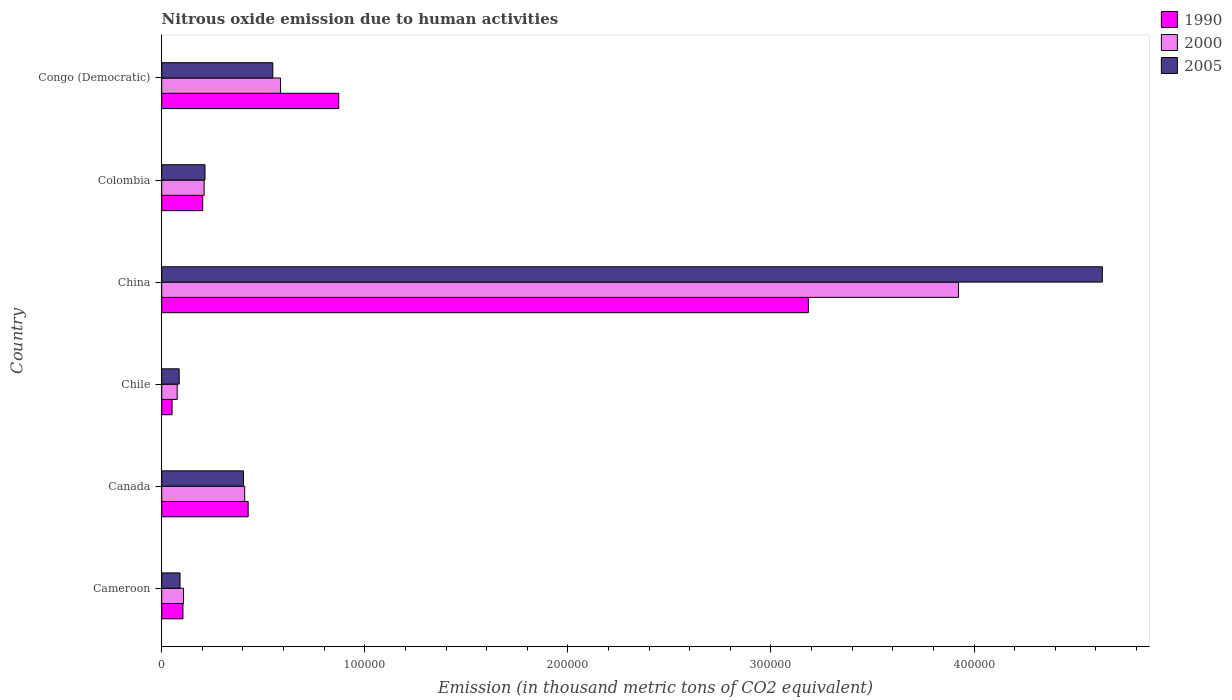How many different coloured bars are there?
Keep it short and to the point. 3. How many groups of bars are there?
Provide a short and direct response. 6. Are the number of bars per tick equal to the number of legend labels?
Offer a very short reply. Yes. Are the number of bars on each tick of the Y-axis equal?
Your answer should be very brief. Yes. What is the label of the 6th group of bars from the top?
Your answer should be very brief. Cameroon. In how many cases, is the number of bars for a given country not equal to the number of legend labels?
Provide a short and direct response. 0. What is the amount of nitrous oxide emitted in 1990 in Congo (Democratic)?
Your answer should be compact. 8.72e+04. Across all countries, what is the maximum amount of nitrous oxide emitted in 2005?
Provide a short and direct response. 4.63e+05. Across all countries, what is the minimum amount of nitrous oxide emitted in 2000?
Your answer should be very brief. 7617.9. In which country was the amount of nitrous oxide emitted in 2005 maximum?
Offer a very short reply. China. What is the total amount of nitrous oxide emitted in 1990 in the graph?
Provide a succinct answer. 4.84e+05. What is the difference between the amount of nitrous oxide emitted in 2005 in Chile and that in China?
Your answer should be very brief. -4.55e+05. What is the difference between the amount of nitrous oxide emitted in 2005 in Canada and the amount of nitrous oxide emitted in 2000 in Congo (Democratic)?
Make the answer very short. -1.83e+04. What is the average amount of nitrous oxide emitted in 2005 per country?
Your response must be concise. 9.95e+04. What is the difference between the amount of nitrous oxide emitted in 2005 and amount of nitrous oxide emitted in 2000 in Cameroon?
Offer a terse response. -1718.6. What is the ratio of the amount of nitrous oxide emitted in 2000 in Canada to that in Congo (Democratic)?
Ensure brevity in your answer.  0.7. Is the amount of nitrous oxide emitted in 1990 in Cameroon less than that in Congo (Democratic)?
Your response must be concise. Yes. Is the difference between the amount of nitrous oxide emitted in 2005 in Canada and Colombia greater than the difference between the amount of nitrous oxide emitted in 2000 in Canada and Colombia?
Your answer should be compact. No. What is the difference between the highest and the second highest amount of nitrous oxide emitted in 2000?
Offer a very short reply. 3.34e+05. What is the difference between the highest and the lowest amount of nitrous oxide emitted in 2005?
Give a very brief answer. 4.55e+05. In how many countries, is the amount of nitrous oxide emitted in 2000 greater than the average amount of nitrous oxide emitted in 2000 taken over all countries?
Ensure brevity in your answer.  1. What does the 1st bar from the top in Congo (Democratic) represents?
Provide a succinct answer. 2005. How many bars are there?
Provide a short and direct response. 18. Are all the bars in the graph horizontal?
Your answer should be compact. Yes. How many countries are there in the graph?
Your answer should be very brief. 6. What is the difference between two consecutive major ticks on the X-axis?
Offer a terse response. 1.00e+05. Are the values on the major ticks of X-axis written in scientific E-notation?
Offer a terse response. No. Does the graph contain grids?
Your answer should be very brief. No. Where does the legend appear in the graph?
Offer a very short reply. Top right. How many legend labels are there?
Offer a very short reply. 3. How are the legend labels stacked?
Keep it short and to the point. Vertical. What is the title of the graph?
Provide a short and direct response. Nitrous oxide emission due to human activities. Does "1974" appear as one of the legend labels in the graph?
Ensure brevity in your answer.  No. What is the label or title of the X-axis?
Ensure brevity in your answer.  Emission (in thousand metric tons of CO2 equivalent). What is the label or title of the Y-axis?
Your answer should be compact. Country. What is the Emission (in thousand metric tons of CO2 equivalent) of 1990 in Cameroon?
Your response must be concise. 1.05e+04. What is the Emission (in thousand metric tons of CO2 equivalent) of 2000 in Cameroon?
Provide a succinct answer. 1.07e+04. What is the Emission (in thousand metric tons of CO2 equivalent) in 2005 in Cameroon?
Make the answer very short. 9027.2. What is the Emission (in thousand metric tons of CO2 equivalent) of 1990 in Canada?
Your response must be concise. 4.26e+04. What is the Emission (in thousand metric tons of CO2 equivalent) in 2000 in Canada?
Ensure brevity in your answer.  4.09e+04. What is the Emission (in thousand metric tons of CO2 equivalent) of 2005 in Canada?
Ensure brevity in your answer.  4.02e+04. What is the Emission (in thousand metric tons of CO2 equivalent) of 1990 in Chile?
Provide a succinct answer. 5100.7. What is the Emission (in thousand metric tons of CO2 equivalent) of 2000 in Chile?
Offer a very short reply. 7617.9. What is the Emission (in thousand metric tons of CO2 equivalent) in 2005 in Chile?
Offer a very short reply. 8607.6. What is the Emission (in thousand metric tons of CO2 equivalent) of 1990 in China?
Give a very brief answer. 3.18e+05. What is the Emission (in thousand metric tons of CO2 equivalent) in 2000 in China?
Your answer should be very brief. 3.92e+05. What is the Emission (in thousand metric tons of CO2 equivalent) in 2005 in China?
Provide a succinct answer. 4.63e+05. What is the Emission (in thousand metric tons of CO2 equivalent) of 1990 in Colombia?
Give a very brief answer. 2.02e+04. What is the Emission (in thousand metric tons of CO2 equivalent) of 2000 in Colombia?
Your response must be concise. 2.09e+04. What is the Emission (in thousand metric tons of CO2 equivalent) of 2005 in Colombia?
Provide a succinct answer. 2.13e+04. What is the Emission (in thousand metric tons of CO2 equivalent) of 1990 in Congo (Democratic)?
Give a very brief answer. 8.72e+04. What is the Emission (in thousand metric tons of CO2 equivalent) in 2000 in Congo (Democratic)?
Provide a short and direct response. 5.85e+04. What is the Emission (in thousand metric tons of CO2 equivalent) of 2005 in Congo (Democratic)?
Provide a short and direct response. 5.47e+04. Across all countries, what is the maximum Emission (in thousand metric tons of CO2 equivalent) of 1990?
Offer a terse response. 3.18e+05. Across all countries, what is the maximum Emission (in thousand metric tons of CO2 equivalent) in 2000?
Keep it short and to the point. 3.92e+05. Across all countries, what is the maximum Emission (in thousand metric tons of CO2 equivalent) of 2005?
Offer a very short reply. 4.63e+05. Across all countries, what is the minimum Emission (in thousand metric tons of CO2 equivalent) of 1990?
Offer a terse response. 5100.7. Across all countries, what is the minimum Emission (in thousand metric tons of CO2 equivalent) in 2000?
Make the answer very short. 7617.9. Across all countries, what is the minimum Emission (in thousand metric tons of CO2 equivalent) of 2005?
Make the answer very short. 8607.6. What is the total Emission (in thousand metric tons of CO2 equivalent) of 1990 in the graph?
Provide a succinct answer. 4.84e+05. What is the total Emission (in thousand metric tons of CO2 equivalent) in 2000 in the graph?
Ensure brevity in your answer.  5.31e+05. What is the total Emission (in thousand metric tons of CO2 equivalent) in 2005 in the graph?
Offer a terse response. 5.97e+05. What is the difference between the Emission (in thousand metric tons of CO2 equivalent) of 1990 in Cameroon and that in Canada?
Offer a terse response. -3.21e+04. What is the difference between the Emission (in thousand metric tons of CO2 equivalent) in 2000 in Cameroon and that in Canada?
Your response must be concise. -3.01e+04. What is the difference between the Emission (in thousand metric tons of CO2 equivalent) in 2005 in Cameroon and that in Canada?
Provide a succinct answer. -3.12e+04. What is the difference between the Emission (in thousand metric tons of CO2 equivalent) of 1990 in Cameroon and that in Chile?
Offer a terse response. 5359.6. What is the difference between the Emission (in thousand metric tons of CO2 equivalent) of 2000 in Cameroon and that in Chile?
Make the answer very short. 3127.9. What is the difference between the Emission (in thousand metric tons of CO2 equivalent) of 2005 in Cameroon and that in Chile?
Your answer should be compact. 419.6. What is the difference between the Emission (in thousand metric tons of CO2 equivalent) in 1990 in Cameroon and that in China?
Give a very brief answer. -3.08e+05. What is the difference between the Emission (in thousand metric tons of CO2 equivalent) of 2000 in Cameroon and that in China?
Your response must be concise. -3.82e+05. What is the difference between the Emission (in thousand metric tons of CO2 equivalent) in 2005 in Cameroon and that in China?
Provide a succinct answer. -4.54e+05. What is the difference between the Emission (in thousand metric tons of CO2 equivalent) of 1990 in Cameroon and that in Colombia?
Your answer should be very brief. -9721.4. What is the difference between the Emission (in thousand metric tons of CO2 equivalent) in 2000 in Cameroon and that in Colombia?
Your answer should be compact. -1.01e+04. What is the difference between the Emission (in thousand metric tons of CO2 equivalent) in 2005 in Cameroon and that in Colombia?
Keep it short and to the point. -1.23e+04. What is the difference between the Emission (in thousand metric tons of CO2 equivalent) of 1990 in Cameroon and that in Congo (Democratic)?
Provide a succinct answer. -7.67e+04. What is the difference between the Emission (in thousand metric tons of CO2 equivalent) in 2000 in Cameroon and that in Congo (Democratic)?
Provide a short and direct response. -4.78e+04. What is the difference between the Emission (in thousand metric tons of CO2 equivalent) of 2005 in Cameroon and that in Congo (Democratic)?
Ensure brevity in your answer.  -4.57e+04. What is the difference between the Emission (in thousand metric tons of CO2 equivalent) in 1990 in Canada and that in Chile?
Keep it short and to the point. 3.75e+04. What is the difference between the Emission (in thousand metric tons of CO2 equivalent) of 2000 in Canada and that in Chile?
Offer a terse response. 3.32e+04. What is the difference between the Emission (in thousand metric tons of CO2 equivalent) of 2005 in Canada and that in Chile?
Give a very brief answer. 3.16e+04. What is the difference between the Emission (in thousand metric tons of CO2 equivalent) in 1990 in Canada and that in China?
Ensure brevity in your answer.  -2.76e+05. What is the difference between the Emission (in thousand metric tons of CO2 equivalent) of 2000 in Canada and that in China?
Offer a very short reply. -3.52e+05. What is the difference between the Emission (in thousand metric tons of CO2 equivalent) of 2005 in Canada and that in China?
Give a very brief answer. -4.23e+05. What is the difference between the Emission (in thousand metric tons of CO2 equivalent) in 1990 in Canada and that in Colombia?
Give a very brief answer. 2.24e+04. What is the difference between the Emission (in thousand metric tons of CO2 equivalent) in 2000 in Canada and that in Colombia?
Offer a very short reply. 2.00e+04. What is the difference between the Emission (in thousand metric tons of CO2 equivalent) in 2005 in Canada and that in Colombia?
Ensure brevity in your answer.  1.89e+04. What is the difference between the Emission (in thousand metric tons of CO2 equivalent) of 1990 in Canada and that in Congo (Democratic)?
Offer a terse response. -4.46e+04. What is the difference between the Emission (in thousand metric tons of CO2 equivalent) in 2000 in Canada and that in Congo (Democratic)?
Your answer should be very brief. -1.77e+04. What is the difference between the Emission (in thousand metric tons of CO2 equivalent) of 2005 in Canada and that in Congo (Democratic)?
Provide a succinct answer. -1.45e+04. What is the difference between the Emission (in thousand metric tons of CO2 equivalent) of 1990 in Chile and that in China?
Provide a short and direct response. -3.13e+05. What is the difference between the Emission (in thousand metric tons of CO2 equivalent) in 2000 in Chile and that in China?
Your answer should be very brief. -3.85e+05. What is the difference between the Emission (in thousand metric tons of CO2 equivalent) in 2005 in Chile and that in China?
Your answer should be compact. -4.55e+05. What is the difference between the Emission (in thousand metric tons of CO2 equivalent) in 1990 in Chile and that in Colombia?
Your answer should be very brief. -1.51e+04. What is the difference between the Emission (in thousand metric tons of CO2 equivalent) of 2000 in Chile and that in Colombia?
Keep it short and to the point. -1.33e+04. What is the difference between the Emission (in thousand metric tons of CO2 equivalent) of 2005 in Chile and that in Colombia?
Your response must be concise. -1.27e+04. What is the difference between the Emission (in thousand metric tons of CO2 equivalent) of 1990 in Chile and that in Congo (Democratic)?
Ensure brevity in your answer.  -8.21e+04. What is the difference between the Emission (in thousand metric tons of CO2 equivalent) of 2000 in Chile and that in Congo (Democratic)?
Your response must be concise. -5.09e+04. What is the difference between the Emission (in thousand metric tons of CO2 equivalent) of 2005 in Chile and that in Congo (Democratic)?
Make the answer very short. -4.61e+04. What is the difference between the Emission (in thousand metric tons of CO2 equivalent) of 1990 in China and that in Colombia?
Your answer should be compact. 2.98e+05. What is the difference between the Emission (in thousand metric tons of CO2 equivalent) in 2000 in China and that in Colombia?
Offer a terse response. 3.71e+05. What is the difference between the Emission (in thousand metric tons of CO2 equivalent) of 2005 in China and that in Colombia?
Give a very brief answer. 4.42e+05. What is the difference between the Emission (in thousand metric tons of CO2 equivalent) of 1990 in China and that in Congo (Democratic)?
Your response must be concise. 2.31e+05. What is the difference between the Emission (in thousand metric tons of CO2 equivalent) of 2000 in China and that in Congo (Democratic)?
Your response must be concise. 3.34e+05. What is the difference between the Emission (in thousand metric tons of CO2 equivalent) in 2005 in China and that in Congo (Democratic)?
Give a very brief answer. 4.08e+05. What is the difference between the Emission (in thousand metric tons of CO2 equivalent) of 1990 in Colombia and that in Congo (Democratic)?
Make the answer very short. -6.70e+04. What is the difference between the Emission (in thousand metric tons of CO2 equivalent) of 2000 in Colombia and that in Congo (Democratic)?
Keep it short and to the point. -3.76e+04. What is the difference between the Emission (in thousand metric tons of CO2 equivalent) of 2005 in Colombia and that in Congo (Democratic)?
Ensure brevity in your answer.  -3.34e+04. What is the difference between the Emission (in thousand metric tons of CO2 equivalent) of 1990 in Cameroon and the Emission (in thousand metric tons of CO2 equivalent) of 2000 in Canada?
Your answer should be compact. -3.04e+04. What is the difference between the Emission (in thousand metric tons of CO2 equivalent) in 1990 in Cameroon and the Emission (in thousand metric tons of CO2 equivalent) in 2005 in Canada?
Your answer should be very brief. -2.98e+04. What is the difference between the Emission (in thousand metric tons of CO2 equivalent) of 2000 in Cameroon and the Emission (in thousand metric tons of CO2 equivalent) of 2005 in Canada?
Your response must be concise. -2.95e+04. What is the difference between the Emission (in thousand metric tons of CO2 equivalent) of 1990 in Cameroon and the Emission (in thousand metric tons of CO2 equivalent) of 2000 in Chile?
Provide a succinct answer. 2842.4. What is the difference between the Emission (in thousand metric tons of CO2 equivalent) in 1990 in Cameroon and the Emission (in thousand metric tons of CO2 equivalent) in 2005 in Chile?
Keep it short and to the point. 1852.7. What is the difference between the Emission (in thousand metric tons of CO2 equivalent) in 2000 in Cameroon and the Emission (in thousand metric tons of CO2 equivalent) in 2005 in Chile?
Your answer should be compact. 2138.2. What is the difference between the Emission (in thousand metric tons of CO2 equivalent) of 1990 in Cameroon and the Emission (in thousand metric tons of CO2 equivalent) of 2000 in China?
Your answer should be compact. -3.82e+05. What is the difference between the Emission (in thousand metric tons of CO2 equivalent) in 1990 in Cameroon and the Emission (in thousand metric tons of CO2 equivalent) in 2005 in China?
Make the answer very short. -4.53e+05. What is the difference between the Emission (in thousand metric tons of CO2 equivalent) of 2000 in Cameroon and the Emission (in thousand metric tons of CO2 equivalent) of 2005 in China?
Provide a succinct answer. -4.52e+05. What is the difference between the Emission (in thousand metric tons of CO2 equivalent) of 1990 in Cameroon and the Emission (in thousand metric tons of CO2 equivalent) of 2000 in Colombia?
Provide a short and direct response. -1.04e+04. What is the difference between the Emission (in thousand metric tons of CO2 equivalent) in 1990 in Cameroon and the Emission (in thousand metric tons of CO2 equivalent) in 2005 in Colombia?
Your answer should be very brief. -1.09e+04. What is the difference between the Emission (in thousand metric tons of CO2 equivalent) in 2000 in Cameroon and the Emission (in thousand metric tons of CO2 equivalent) in 2005 in Colombia?
Provide a short and direct response. -1.06e+04. What is the difference between the Emission (in thousand metric tons of CO2 equivalent) of 1990 in Cameroon and the Emission (in thousand metric tons of CO2 equivalent) of 2000 in Congo (Democratic)?
Offer a terse response. -4.81e+04. What is the difference between the Emission (in thousand metric tons of CO2 equivalent) in 1990 in Cameroon and the Emission (in thousand metric tons of CO2 equivalent) in 2005 in Congo (Democratic)?
Your response must be concise. -4.42e+04. What is the difference between the Emission (in thousand metric tons of CO2 equivalent) in 2000 in Cameroon and the Emission (in thousand metric tons of CO2 equivalent) in 2005 in Congo (Democratic)?
Keep it short and to the point. -4.40e+04. What is the difference between the Emission (in thousand metric tons of CO2 equivalent) in 1990 in Canada and the Emission (in thousand metric tons of CO2 equivalent) in 2000 in Chile?
Provide a short and direct response. 3.50e+04. What is the difference between the Emission (in thousand metric tons of CO2 equivalent) of 1990 in Canada and the Emission (in thousand metric tons of CO2 equivalent) of 2005 in Chile?
Provide a succinct answer. 3.40e+04. What is the difference between the Emission (in thousand metric tons of CO2 equivalent) in 2000 in Canada and the Emission (in thousand metric tons of CO2 equivalent) in 2005 in Chile?
Provide a succinct answer. 3.23e+04. What is the difference between the Emission (in thousand metric tons of CO2 equivalent) in 1990 in Canada and the Emission (in thousand metric tons of CO2 equivalent) in 2000 in China?
Provide a succinct answer. -3.50e+05. What is the difference between the Emission (in thousand metric tons of CO2 equivalent) of 1990 in Canada and the Emission (in thousand metric tons of CO2 equivalent) of 2005 in China?
Make the answer very short. -4.21e+05. What is the difference between the Emission (in thousand metric tons of CO2 equivalent) in 2000 in Canada and the Emission (in thousand metric tons of CO2 equivalent) in 2005 in China?
Provide a short and direct response. -4.22e+05. What is the difference between the Emission (in thousand metric tons of CO2 equivalent) of 1990 in Canada and the Emission (in thousand metric tons of CO2 equivalent) of 2000 in Colombia?
Provide a succinct answer. 2.17e+04. What is the difference between the Emission (in thousand metric tons of CO2 equivalent) of 1990 in Canada and the Emission (in thousand metric tons of CO2 equivalent) of 2005 in Colombia?
Keep it short and to the point. 2.13e+04. What is the difference between the Emission (in thousand metric tons of CO2 equivalent) in 2000 in Canada and the Emission (in thousand metric tons of CO2 equivalent) in 2005 in Colombia?
Ensure brevity in your answer.  1.95e+04. What is the difference between the Emission (in thousand metric tons of CO2 equivalent) of 1990 in Canada and the Emission (in thousand metric tons of CO2 equivalent) of 2000 in Congo (Democratic)?
Give a very brief answer. -1.60e+04. What is the difference between the Emission (in thousand metric tons of CO2 equivalent) of 1990 in Canada and the Emission (in thousand metric tons of CO2 equivalent) of 2005 in Congo (Democratic)?
Provide a succinct answer. -1.21e+04. What is the difference between the Emission (in thousand metric tons of CO2 equivalent) in 2000 in Canada and the Emission (in thousand metric tons of CO2 equivalent) in 2005 in Congo (Democratic)?
Provide a short and direct response. -1.38e+04. What is the difference between the Emission (in thousand metric tons of CO2 equivalent) of 1990 in Chile and the Emission (in thousand metric tons of CO2 equivalent) of 2000 in China?
Your answer should be very brief. -3.87e+05. What is the difference between the Emission (in thousand metric tons of CO2 equivalent) in 1990 in Chile and the Emission (in thousand metric tons of CO2 equivalent) in 2005 in China?
Your response must be concise. -4.58e+05. What is the difference between the Emission (in thousand metric tons of CO2 equivalent) of 2000 in Chile and the Emission (in thousand metric tons of CO2 equivalent) of 2005 in China?
Ensure brevity in your answer.  -4.56e+05. What is the difference between the Emission (in thousand metric tons of CO2 equivalent) of 1990 in Chile and the Emission (in thousand metric tons of CO2 equivalent) of 2000 in Colombia?
Keep it short and to the point. -1.58e+04. What is the difference between the Emission (in thousand metric tons of CO2 equivalent) of 1990 in Chile and the Emission (in thousand metric tons of CO2 equivalent) of 2005 in Colombia?
Your answer should be compact. -1.62e+04. What is the difference between the Emission (in thousand metric tons of CO2 equivalent) of 2000 in Chile and the Emission (in thousand metric tons of CO2 equivalent) of 2005 in Colombia?
Your response must be concise. -1.37e+04. What is the difference between the Emission (in thousand metric tons of CO2 equivalent) in 1990 in Chile and the Emission (in thousand metric tons of CO2 equivalent) in 2000 in Congo (Democratic)?
Offer a very short reply. -5.34e+04. What is the difference between the Emission (in thousand metric tons of CO2 equivalent) in 1990 in Chile and the Emission (in thousand metric tons of CO2 equivalent) in 2005 in Congo (Democratic)?
Your answer should be very brief. -4.96e+04. What is the difference between the Emission (in thousand metric tons of CO2 equivalent) of 2000 in Chile and the Emission (in thousand metric tons of CO2 equivalent) of 2005 in Congo (Democratic)?
Your answer should be very brief. -4.71e+04. What is the difference between the Emission (in thousand metric tons of CO2 equivalent) of 1990 in China and the Emission (in thousand metric tons of CO2 equivalent) of 2000 in Colombia?
Offer a terse response. 2.98e+05. What is the difference between the Emission (in thousand metric tons of CO2 equivalent) in 1990 in China and the Emission (in thousand metric tons of CO2 equivalent) in 2005 in Colombia?
Offer a very short reply. 2.97e+05. What is the difference between the Emission (in thousand metric tons of CO2 equivalent) in 2000 in China and the Emission (in thousand metric tons of CO2 equivalent) in 2005 in Colombia?
Offer a very short reply. 3.71e+05. What is the difference between the Emission (in thousand metric tons of CO2 equivalent) of 1990 in China and the Emission (in thousand metric tons of CO2 equivalent) of 2000 in Congo (Democratic)?
Make the answer very short. 2.60e+05. What is the difference between the Emission (in thousand metric tons of CO2 equivalent) of 1990 in China and the Emission (in thousand metric tons of CO2 equivalent) of 2005 in Congo (Democratic)?
Keep it short and to the point. 2.64e+05. What is the difference between the Emission (in thousand metric tons of CO2 equivalent) in 2000 in China and the Emission (in thousand metric tons of CO2 equivalent) in 2005 in Congo (Democratic)?
Provide a succinct answer. 3.38e+05. What is the difference between the Emission (in thousand metric tons of CO2 equivalent) in 1990 in Colombia and the Emission (in thousand metric tons of CO2 equivalent) in 2000 in Congo (Democratic)?
Offer a terse response. -3.83e+04. What is the difference between the Emission (in thousand metric tons of CO2 equivalent) in 1990 in Colombia and the Emission (in thousand metric tons of CO2 equivalent) in 2005 in Congo (Democratic)?
Provide a succinct answer. -3.45e+04. What is the difference between the Emission (in thousand metric tons of CO2 equivalent) of 2000 in Colombia and the Emission (in thousand metric tons of CO2 equivalent) of 2005 in Congo (Democratic)?
Your response must be concise. -3.38e+04. What is the average Emission (in thousand metric tons of CO2 equivalent) of 1990 per country?
Provide a short and direct response. 8.06e+04. What is the average Emission (in thousand metric tons of CO2 equivalent) of 2000 per country?
Your answer should be very brief. 8.85e+04. What is the average Emission (in thousand metric tons of CO2 equivalent) in 2005 per country?
Make the answer very short. 9.95e+04. What is the difference between the Emission (in thousand metric tons of CO2 equivalent) in 1990 and Emission (in thousand metric tons of CO2 equivalent) in 2000 in Cameroon?
Offer a terse response. -285.5. What is the difference between the Emission (in thousand metric tons of CO2 equivalent) of 1990 and Emission (in thousand metric tons of CO2 equivalent) of 2005 in Cameroon?
Give a very brief answer. 1433.1. What is the difference between the Emission (in thousand metric tons of CO2 equivalent) in 2000 and Emission (in thousand metric tons of CO2 equivalent) in 2005 in Cameroon?
Offer a terse response. 1718.6. What is the difference between the Emission (in thousand metric tons of CO2 equivalent) of 1990 and Emission (in thousand metric tons of CO2 equivalent) of 2000 in Canada?
Keep it short and to the point. 1712.6. What is the difference between the Emission (in thousand metric tons of CO2 equivalent) in 1990 and Emission (in thousand metric tons of CO2 equivalent) in 2005 in Canada?
Make the answer very short. 2329.2. What is the difference between the Emission (in thousand metric tons of CO2 equivalent) in 2000 and Emission (in thousand metric tons of CO2 equivalent) in 2005 in Canada?
Your response must be concise. 616.6. What is the difference between the Emission (in thousand metric tons of CO2 equivalent) in 1990 and Emission (in thousand metric tons of CO2 equivalent) in 2000 in Chile?
Your response must be concise. -2517.2. What is the difference between the Emission (in thousand metric tons of CO2 equivalent) of 1990 and Emission (in thousand metric tons of CO2 equivalent) of 2005 in Chile?
Keep it short and to the point. -3506.9. What is the difference between the Emission (in thousand metric tons of CO2 equivalent) of 2000 and Emission (in thousand metric tons of CO2 equivalent) of 2005 in Chile?
Offer a terse response. -989.7. What is the difference between the Emission (in thousand metric tons of CO2 equivalent) in 1990 and Emission (in thousand metric tons of CO2 equivalent) in 2000 in China?
Give a very brief answer. -7.40e+04. What is the difference between the Emission (in thousand metric tons of CO2 equivalent) in 1990 and Emission (in thousand metric tons of CO2 equivalent) in 2005 in China?
Your answer should be compact. -1.45e+05. What is the difference between the Emission (in thousand metric tons of CO2 equivalent) in 2000 and Emission (in thousand metric tons of CO2 equivalent) in 2005 in China?
Provide a short and direct response. -7.08e+04. What is the difference between the Emission (in thousand metric tons of CO2 equivalent) of 1990 and Emission (in thousand metric tons of CO2 equivalent) of 2000 in Colombia?
Make the answer very short. -706.7. What is the difference between the Emission (in thousand metric tons of CO2 equivalent) of 1990 and Emission (in thousand metric tons of CO2 equivalent) of 2005 in Colombia?
Give a very brief answer. -1134.8. What is the difference between the Emission (in thousand metric tons of CO2 equivalent) of 2000 and Emission (in thousand metric tons of CO2 equivalent) of 2005 in Colombia?
Offer a very short reply. -428.1. What is the difference between the Emission (in thousand metric tons of CO2 equivalent) in 1990 and Emission (in thousand metric tons of CO2 equivalent) in 2000 in Congo (Democratic)?
Make the answer very short. 2.86e+04. What is the difference between the Emission (in thousand metric tons of CO2 equivalent) in 1990 and Emission (in thousand metric tons of CO2 equivalent) in 2005 in Congo (Democratic)?
Offer a very short reply. 3.25e+04. What is the difference between the Emission (in thousand metric tons of CO2 equivalent) of 2000 and Emission (in thousand metric tons of CO2 equivalent) of 2005 in Congo (Democratic)?
Make the answer very short. 3826.5. What is the ratio of the Emission (in thousand metric tons of CO2 equivalent) in 1990 in Cameroon to that in Canada?
Your answer should be very brief. 0.25. What is the ratio of the Emission (in thousand metric tons of CO2 equivalent) in 2000 in Cameroon to that in Canada?
Your answer should be very brief. 0.26. What is the ratio of the Emission (in thousand metric tons of CO2 equivalent) in 2005 in Cameroon to that in Canada?
Your response must be concise. 0.22. What is the ratio of the Emission (in thousand metric tons of CO2 equivalent) in 1990 in Cameroon to that in Chile?
Provide a succinct answer. 2.05. What is the ratio of the Emission (in thousand metric tons of CO2 equivalent) in 2000 in Cameroon to that in Chile?
Make the answer very short. 1.41. What is the ratio of the Emission (in thousand metric tons of CO2 equivalent) in 2005 in Cameroon to that in Chile?
Provide a succinct answer. 1.05. What is the ratio of the Emission (in thousand metric tons of CO2 equivalent) of 1990 in Cameroon to that in China?
Your answer should be compact. 0.03. What is the ratio of the Emission (in thousand metric tons of CO2 equivalent) of 2000 in Cameroon to that in China?
Ensure brevity in your answer.  0.03. What is the ratio of the Emission (in thousand metric tons of CO2 equivalent) of 2005 in Cameroon to that in China?
Provide a succinct answer. 0.02. What is the ratio of the Emission (in thousand metric tons of CO2 equivalent) of 1990 in Cameroon to that in Colombia?
Offer a terse response. 0.52. What is the ratio of the Emission (in thousand metric tons of CO2 equivalent) of 2000 in Cameroon to that in Colombia?
Ensure brevity in your answer.  0.51. What is the ratio of the Emission (in thousand metric tons of CO2 equivalent) of 2005 in Cameroon to that in Colombia?
Offer a terse response. 0.42. What is the ratio of the Emission (in thousand metric tons of CO2 equivalent) in 1990 in Cameroon to that in Congo (Democratic)?
Offer a very short reply. 0.12. What is the ratio of the Emission (in thousand metric tons of CO2 equivalent) in 2000 in Cameroon to that in Congo (Democratic)?
Give a very brief answer. 0.18. What is the ratio of the Emission (in thousand metric tons of CO2 equivalent) in 2005 in Cameroon to that in Congo (Democratic)?
Ensure brevity in your answer.  0.17. What is the ratio of the Emission (in thousand metric tons of CO2 equivalent) of 1990 in Canada to that in Chile?
Keep it short and to the point. 8.35. What is the ratio of the Emission (in thousand metric tons of CO2 equivalent) in 2000 in Canada to that in Chile?
Give a very brief answer. 5.36. What is the ratio of the Emission (in thousand metric tons of CO2 equivalent) of 2005 in Canada to that in Chile?
Ensure brevity in your answer.  4.68. What is the ratio of the Emission (in thousand metric tons of CO2 equivalent) of 1990 in Canada to that in China?
Ensure brevity in your answer.  0.13. What is the ratio of the Emission (in thousand metric tons of CO2 equivalent) of 2000 in Canada to that in China?
Your answer should be compact. 0.1. What is the ratio of the Emission (in thousand metric tons of CO2 equivalent) of 2005 in Canada to that in China?
Keep it short and to the point. 0.09. What is the ratio of the Emission (in thousand metric tons of CO2 equivalent) in 1990 in Canada to that in Colombia?
Offer a terse response. 2.11. What is the ratio of the Emission (in thousand metric tons of CO2 equivalent) in 2000 in Canada to that in Colombia?
Your response must be concise. 1.96. What is the ratio of the Emission (in thousand metric tons of CO2 equivalent) of 2005 in Canada to that in Colombia?
Provide a succinct answer. 1.89. What is the ratio of the Emission (in thousand metric tons of CO2 equivalent) of 1990 in Canada to that in Congo (Democratic)?
Give a very brief answer. 0.49. What is the ratio of the Emission (in thousand metric tons of CO2 equivalent) of 2000 in Canada to that in Congo (Democratic)?
Ensure brevity in your answer.  0.7. What is the ratio of the Emission (in thousand metric tons of CO2 equivalent) of 2005 in Canada to that in Congo (Democratic)?
Give a very brief answer. 0.74. What is the ratio of the Emission (in thousand metric tons of CO2 equivalent) of 1990 in Chile to that in China?
Your answer should be very brief. 0.02. What is the ratio of the Emission (in thousand metric tons of CO2 equivalent) in 2000 in Chile to that in China?
Make the answer very short. 0.02. What is the ratio of the Emission (in thousand metric tons of CO2 equivalent) in 2005 in Chile to that in China?
Make the answer very short. 0.02. What is the ratio of the Emission (in thousand metric tons of CO2 equivalent) of 1990 in Chile to that in Colombia?
Your answer should be compact. 0.25. What is the ratio of the Emission (in thousand metric tons of CO2 equivalent) in 2000 in Chile to that in Colombia?
Offer a very short reply. 0.36. What is the ratio of the Emission (in thousand metric tons of CO2 equivalent) in 2005 in Chile to that in Colombia?
Your response must be concise. 0.4. What is the ratio of the Emission (in thousand metric tons of CO2 equivalent) in 1990 in Chile to that in Congo (Democratic)?
Offer a terse response. 0.06. What is the ratio of the Emission (in thousand metric tons of CO2 equivalent) in 2000 in Chile to that in Congo (Democratic)?
Your answer should be very brief. 0.13. What is the ratio of the Emission (in thousand metric tons of CO2 equivalent) in 2005 in Chile to that in Congo (Democratic)?
Offer a very short reply. 0.16. What is the ratio of the Emission (in thousand metric tons of CO2 equivalent) of 1990 in China to that in Colombia?
Offer a very short reply. 15.78. What is the ratio of the Emission (in thousand metric tons of CO2 equivalent) of 2000 in China to that in Colombia?
Your response must be concise. 18.78. What is the ratio of the Emission (in thousand metric tons of CO2 equivalent) in 2005 in China to that in Colombia?
Your answer should be very brief. 21.73. What is the ratio of the Emission (in thousand metric tons of CO2 equivalent) in 1990 in China to that in Congo (Democratic)?
Make the answer very short. 3.65. What is the ratio of the Emission (in thousand metric tons of CO2 equivalent) of 2000 in China to that in Congo (Democratic)?
Make the answer very short. 6.7. What is the ratio of the Emission (in thousand metric tons of CO2 equivalent) in 2005 in China to that in Congo (Democratic)?
Offer a very short reply. 8.47. What is the ratio of the Emission (in thousand metric tons of CO2 equivalent) in 1990 in Colombia to that in Congo (Democratic)?
Your response must be concise. 0.23. What is the ratio of the Emission (in thousand metric tons of CO2 equivalent) in 2000 in Colombia to that in Congo (Democratic)?
Your response must be concise. 0.36. What is the ratio of the Emission (in thousand metric tons of CO2 equivalent) in 2005 in Colombia to that in Congo (Democratic)?
Offer a very short reply. 0.39. What is the difference between the highest and the second highest Emission (in thousand metric tons of CO2 equivalent) in 1990?
Provide a succinct answer. 2.31e+05. What is the difference between the highest and the second highest Emission (in thousand metric tons of CO2 equivalent) of 2000?
Your response must be concise. 3.34e+05. What is the difference between the highest and the second highest Emission (in thousand metric tons of CO2 equivalent) of 2005?
Provide a short and direct response. 4.08e+05. What is the difference between the highest and the lowest Emission (in thousand metric tons of CO2 equivalent) of 1990?
Your response must be concise. 3.13e+05. What is the difference between the highest and the lowest Emission (in thousand metric tons of CO2 equivalent) of 2000?
Your answer should be very brief. 3.85e+05. What is the difference between the highest and the lowest Emission (in thousand metric tons of CO2 equivalent) of 2005?
Provide a succinct answer. 4.55e+05. 